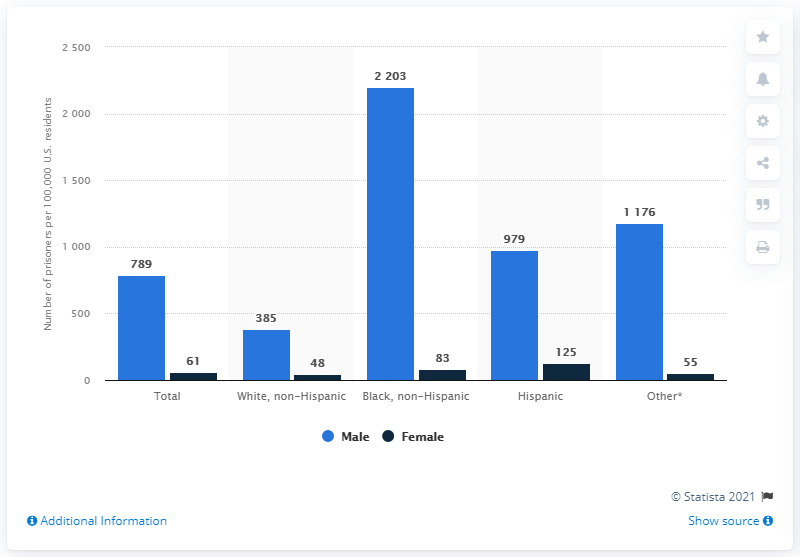Give some essential details in this illustration. According to data, the race with the highest male imprisonment rate is Black, non-Hispanic. According to the data provided, the average number of females imprisoned is 74.4 per year. 